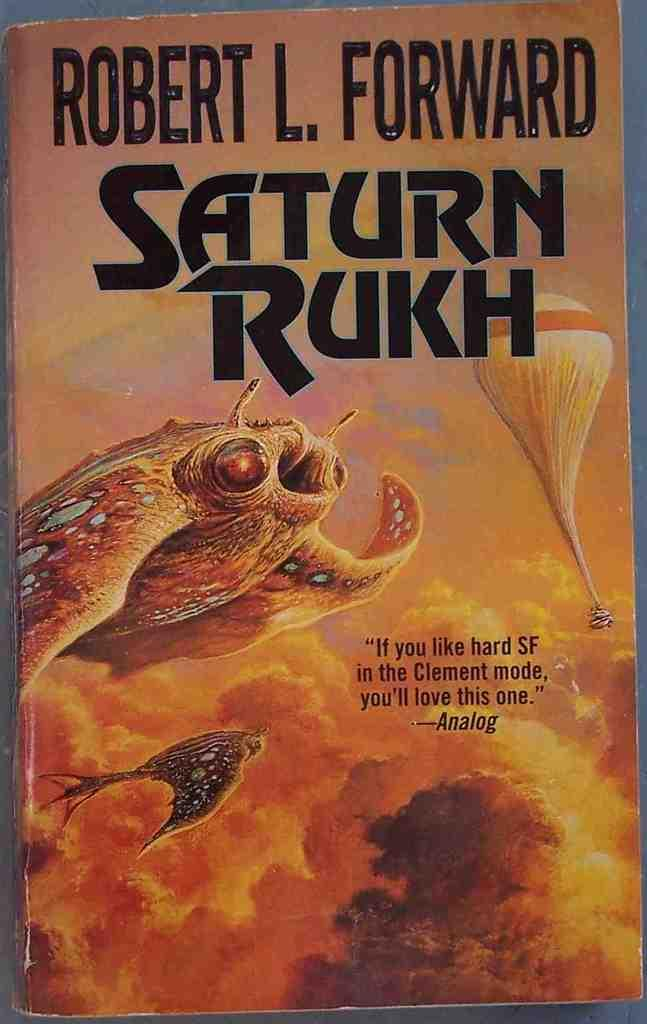<image>
Describe the image concisely. A book by Robert L. Forward titled Saturn Rukh. 